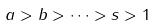<formula> <loc_0><loc_0><loc_500><loc_500>a > b > \dots > s > 1</formula> 